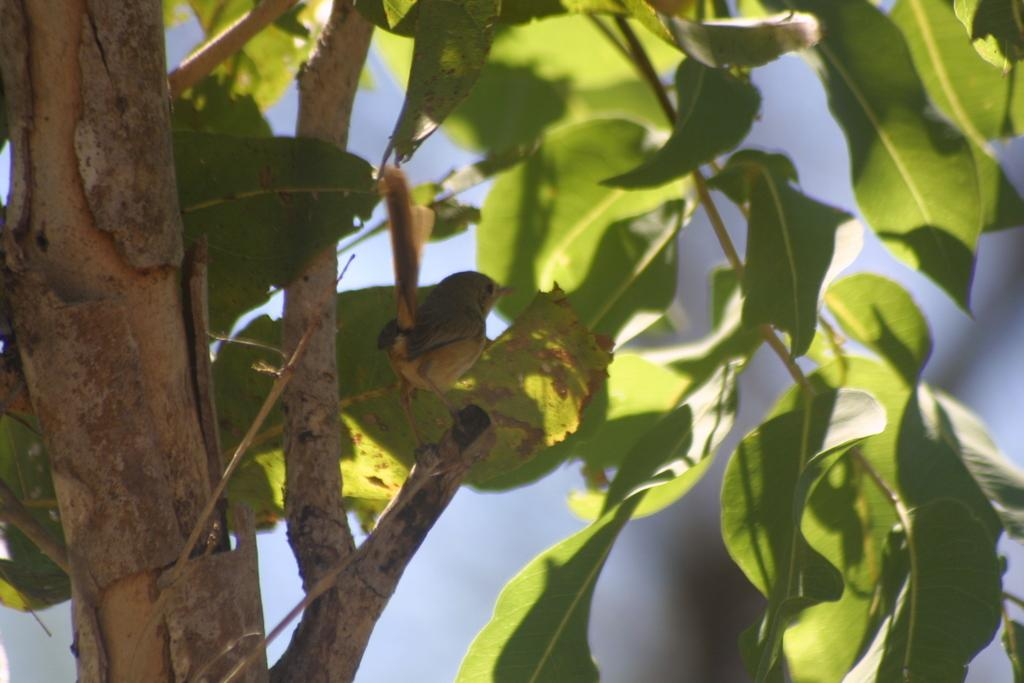What is on the tree in the image? There is a bird on a tree in the image. What can be seen in the background of the image? There are trees in the background of the image. What flavor of ice cream is the bird holding in the image? There is no ice cream present in the image, and the bird is not holding anything. 